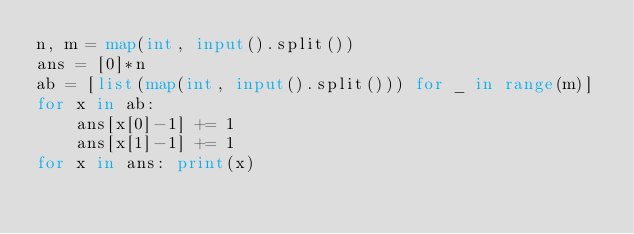Convert code to text. <code><loc_0><loc_0><loc_500><loc_500><_Python_>n, m = map(int, input().split())
ans = [0]*n
ab = [list(map(int, input().split())) for _ in range(m)]
for x in ab:
    ans[x[0]-1] += 1
    ans[x[1]-1] += 1
for x in ans: print(x)
</code> 